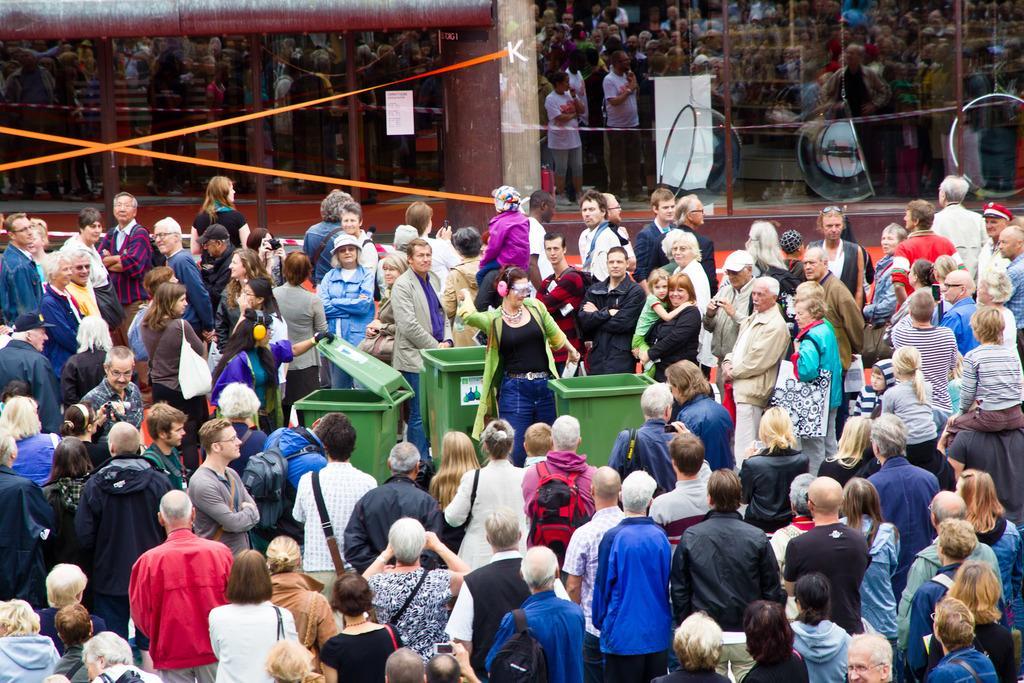Can you describe this image briefly? In this image, we can see people and some are wearing bags and holding some objects and we can see a lady wearing headset and glasses and there are bins. In the background, we can see glass doors, ribbons and some other objects. 